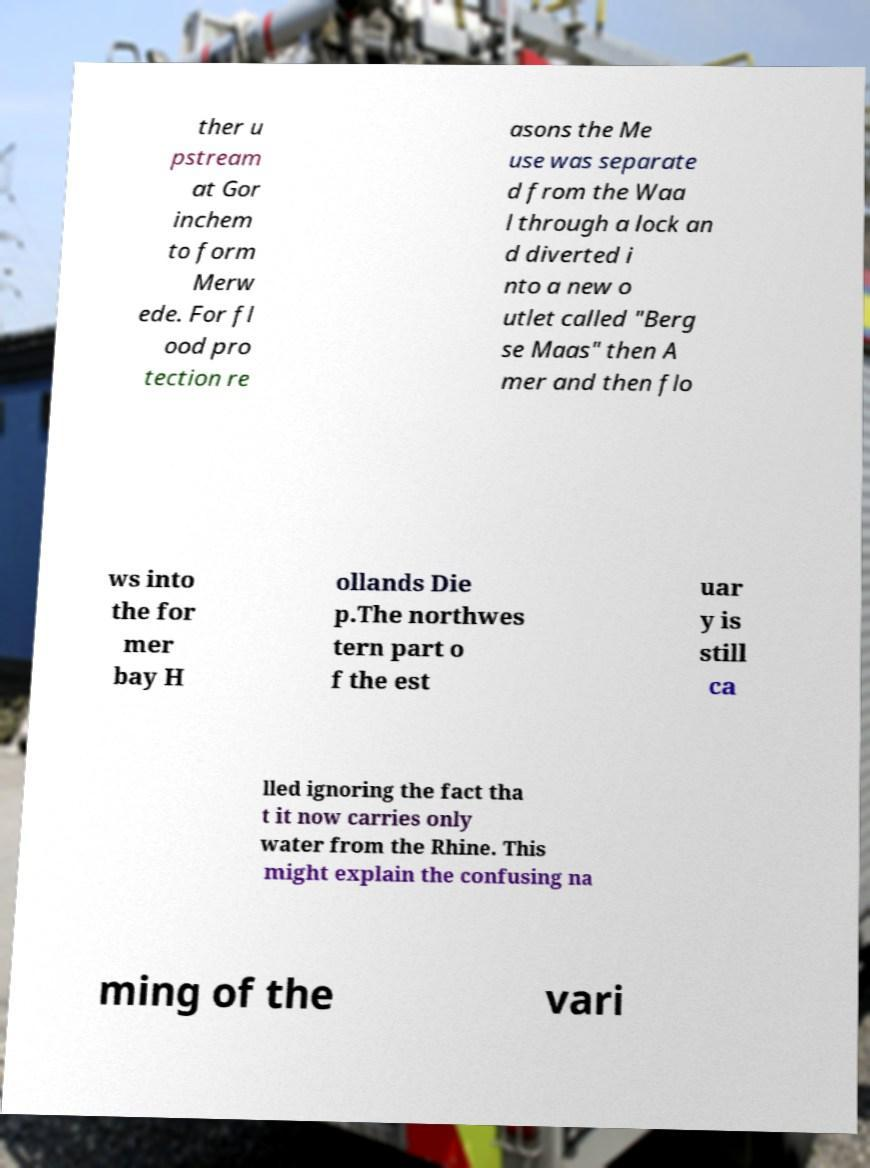Can you read and provide the text displayed in the image?This photo seems to have some interesting text. Can you extract and type it out for me? ther u pstream at Gor inchem to form Merw ede. For fl ood pro tection re asons the Me use was separate d from the Waa l through a lock an d diverted i nto a new o utlet called "Berg se Maas" then A mer and then flo ws into the for mer bay H ollands Die p.The northwes tern part o f the est uar y is still ca lled ignoring the fact tha t it now carries only water from the Rhine. This might explain the confusing na ming of the vari 